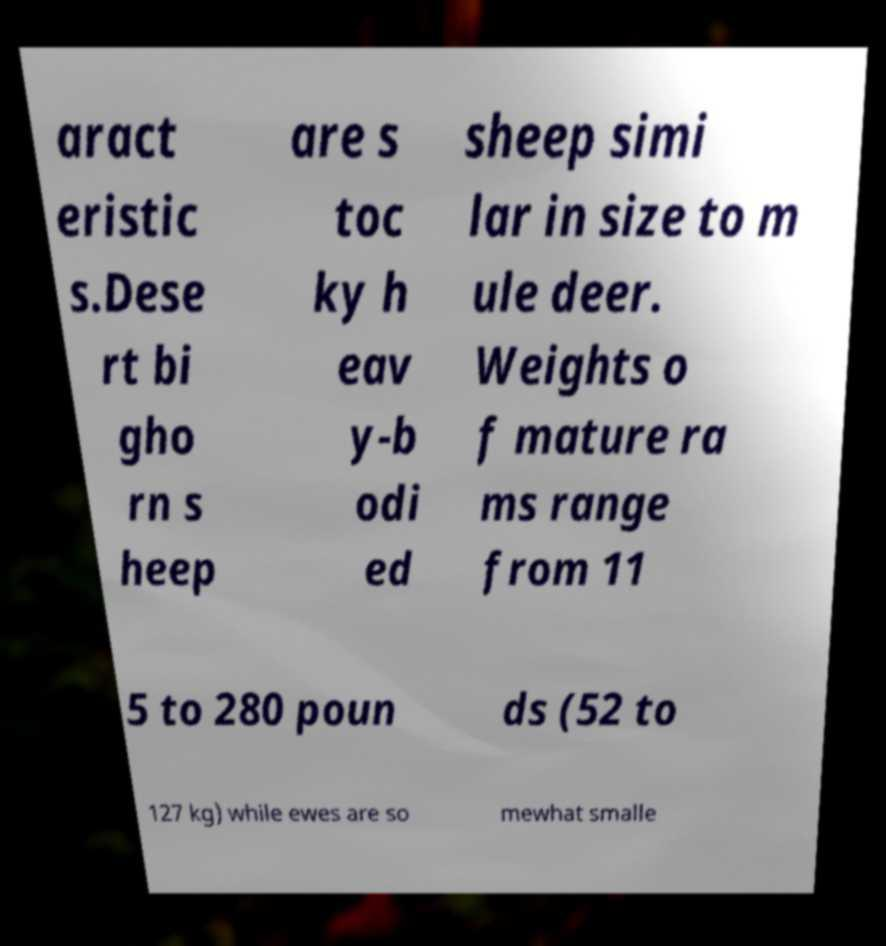Can you accurately transcribe the text from the provided image for me? aract eristic s.Dese rt bi gho rn s heep are s toc ky h eav y-b odi ed sheep simi lar in size to m ule deer. Weights o f mature ra ms range from 11 5 to 280 poun ds (52 to 127 kg) while ewes are so mewhat smalle 